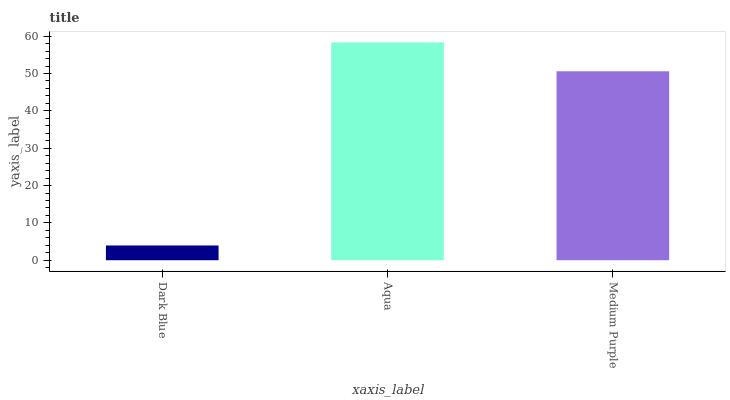Is Dark Blue the minimum?
Answer yes or no. Yes. Is Aqua the maximum?
Answer yes or no. Yes. Is Medium Purple the minimum?
Answer yes or no. No. Is Medium Purple the maximum?
Answer yes or no. No. Is Aqua greater than Medium Purple?
Answer yes or no. Yes. Is Medium Purple less than Aqua?
Answer yes or no. Yes. Is Medium Purple greater than Aqua?
Answer yes or no. No. Is Aqua less than Medium Purple?
Answer yes or no. No. Is Medium Purple the high median?
Answer yes or no. Yes. Is Medium Purple the low median?
Answer yes or no. Yes. Is Aqua the high median?
Answer yes or no. No. Is Dark Blue the low median?
Answer yes or no. No. 